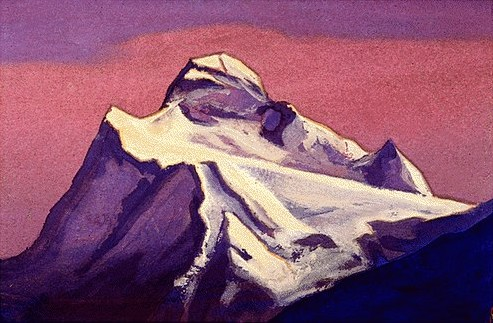What time of day or year might this image represent and why? The color palette with dominant purples and pinks in the sky typically suggests either dawn or dusk due to the soft, diffuse light typically seen at these times. The presence of snow might indicate a setting in late winter or early spring, capturing a transient moment where the harshness of winter begins to give way to the promise of warmer seasons. 